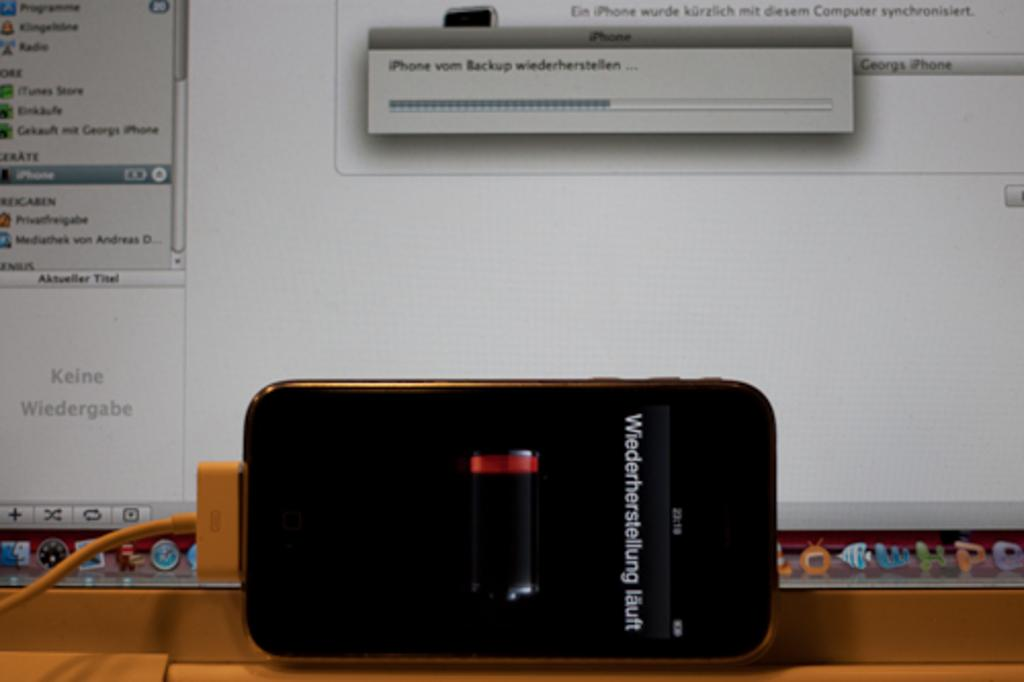<image>
Give a short and clear explanation of the subsequent image. an iphone with no battery plugged into an apple desktop computer 